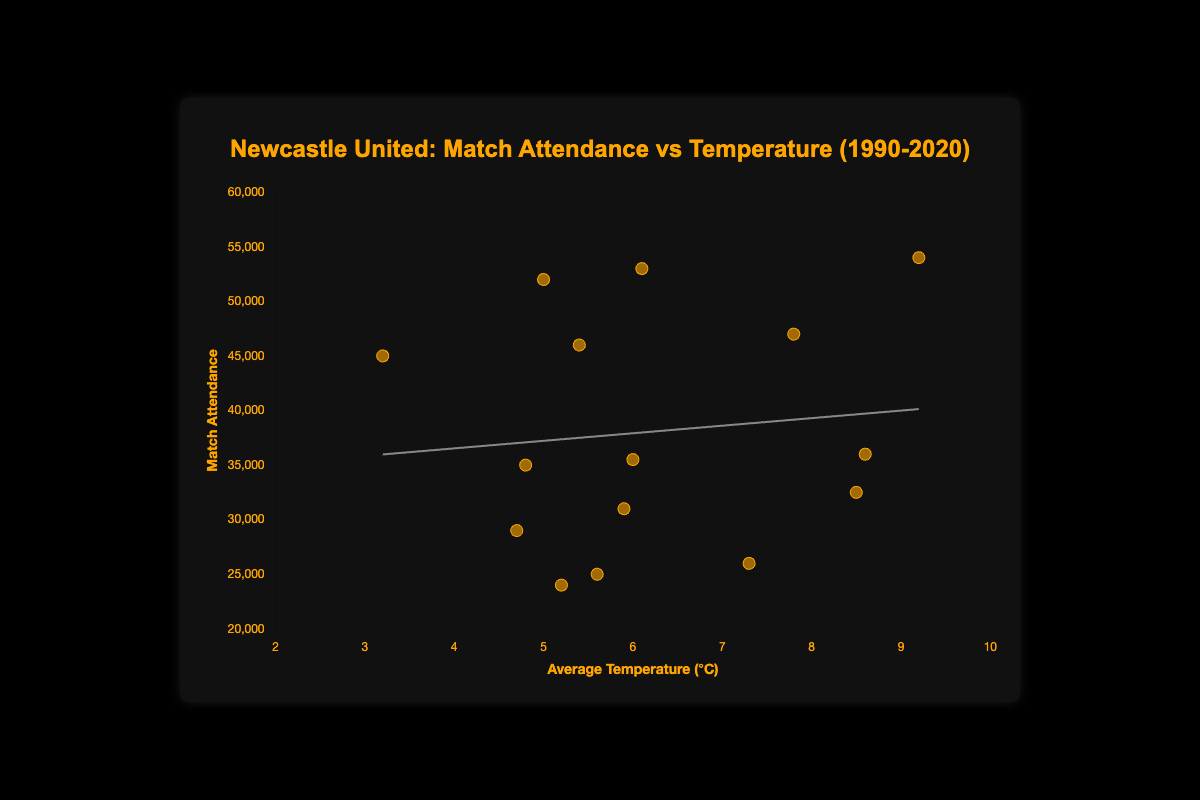What is the title of the figure? The title is shown at the top center of the figure, in orange text.
Answer: Newcastle United: Match Attendance vs Temperature (1990-2020) What is the range of the x-axis? The x-axis shows the average temperature (°C), and the scale is visually set from 2°C to 10°C.
Answer: 2°C to 10°C Which month from 2020 had the highest attendance? By observing the data points and tooltip information for the year 2020, we identify that March 2020 had an average temperature of 9.2°C and the highest attendance of 54,000.
Answer: March What is the color of the data points? The color of the data points is visible as orange, both in the chart and legend.
Answer: Orange What is the average attendance in January for all years combined? The attendances for January across the years are: 1990 (24000), 1994 (29000), 2000 (35000), 2010 (45000), 2020 (52000). Summing these and dividing by 5 (number of years): (24000 + 29000 + 35000 + 45000 + 52000) / 5 = 37000.
Answer: 37000 Does the trend line suggest a positive or negative correlation between temperature and attendance? The trend line on the scatter plot slopes upwards from left to right, indicating a positive correlation.
Answer: Positive Which year witnessed the lowest average temperature for March and what was its corresponding attendance? Observing the data points and tooltips, March 2010 had the lowest average temperature (7.8°C) for March, with an attendance of 47,000.
Answer: 2010, 47,000 Compare the attendance in February 1994 and February 2020. Which is higher and by how much? February 1994 had an attendance of 31,000, while February 2020 had an attendance of 53,000. The difference is calculated by: 53,000 - 31,000 = 22,000.
Answer: February 2020, 22,000 What is the general trend visible when the temperature increases from 5°C to 9°C? The scatter plot with the trend line shows that as the temperature increases from 5°C to 9°C, the match attendance tends to increase as well.
Answer: Attendance increases By how much did the average March temperature increase from 1990 to 2020? The average March temperature in 1990 was 7.3°C. For 2020, it was 9.2°C. The increase is calculated as 9.2 - 7.3 = 1.9°C.
Answer: 1.9°C 